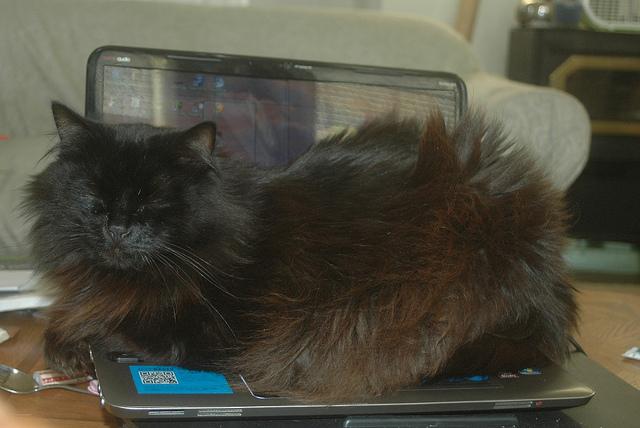What is the cat sitting on?
Give a very brief answer. Laptop. What color is the cat?
Answer briefly. Brown. Is this a cat?
Answer briefly. Yes. Is the cat asleep?
Keep it brief. Yes. Would most people think this animal is cute?
Concise answer only. Yes. What kind of animal is this?
Short answer required. Cat. 